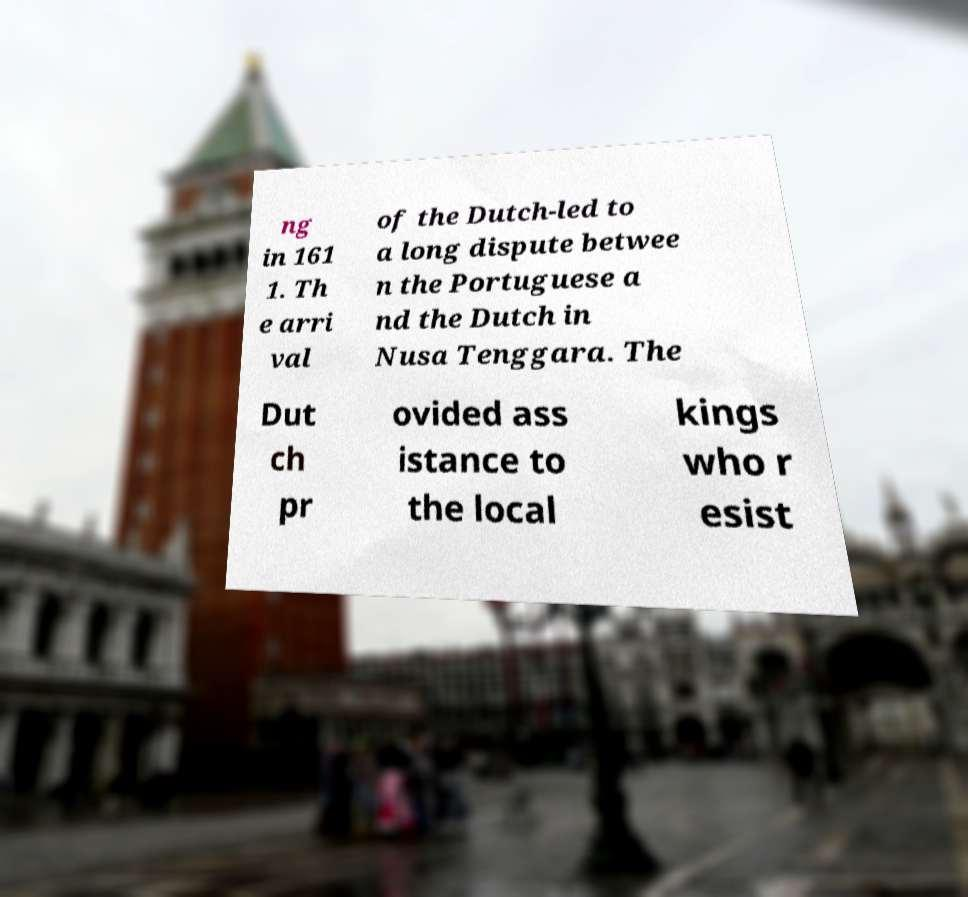Please read and relay the text visible in this image. What does it say? ng in 161 1. Th e arri val of the Dutch-led to a long dispute betwee n the Portuguese a nd the Dutch in Nusa Tenggara. The Dut ch pr ovided ass istance to the local kings who r esist 